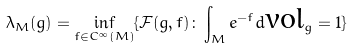<formula> <loc_0><loc_0><loc_500><loc_500>\lambda _ { M } ( g ) = \inf _ { f \in C ^ { \infty } ( M ) } \{ \mathcal { F } ( g , f ) \colon \int _ { M } e ^ { - f } d \text {vol} _ { g } = 1 \}</formula> 